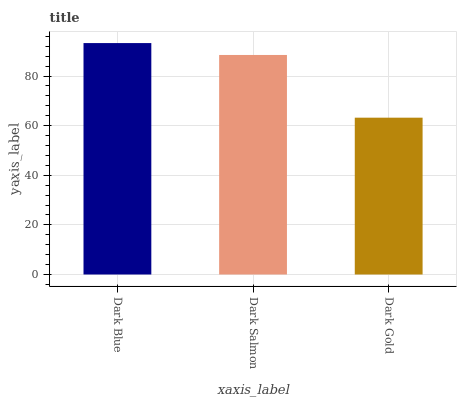Is Dark Blue the maximum?
Answer yes or no. Yes. Is Dark Salmon the minimum?
Answer yes or no. No. Is Dark Salmon the maximum?
Answer yes or no. No. Is Dark Blue greater than Dark Salmon?
Answer yes or no. Yes. Is Dark Salmon less than Dark Blue?
Answer yes or no. Yes. Is Dark Salmon greater than Dark Blue?
Answer yes or no. No. Is Dark Blue less than Dark Salmon?
Answer yes or no. No. Is Dark Salmon the high median?
Answer yes or no. Yes. Is Dark Salmon the low median?
Answer yes or no. Yes. Is Dark Gold the high median?
Answer yes or no. No. Is Dark Gold the low median?
Answer yes or no. No. 